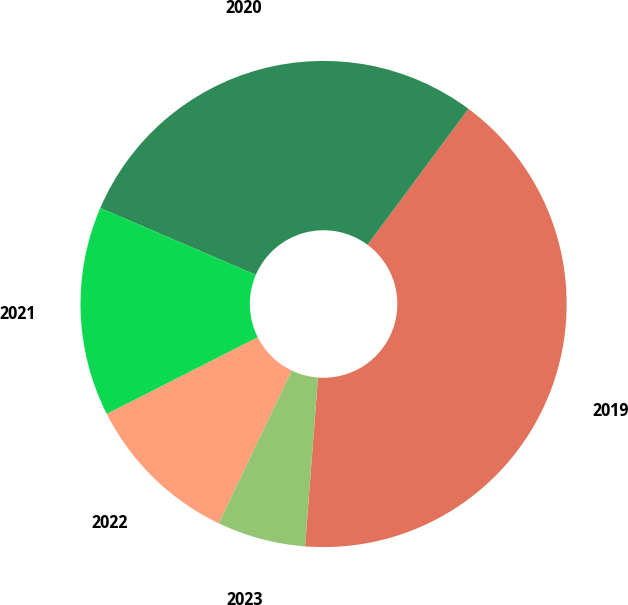<chart> <loc_0><loc_0><loc_500><loc_500><pie_chart><fcel>2019<fcel>2020<fcel>2021<fcel>2022<fcel>2023<nl><fcel>41.05%<fcel>28.7%<fcel>13.94%<fcel>10.43%<fcel>5.88%<nl></chart> 